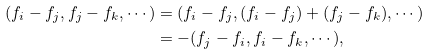Convert formula to latex. <formula><loc_0><loc_0><loc_500><loc_500>( f _ { i } - f _ { j } , f _ { j } - f _ { k } , \cdots ) & = ( f _ { i } - f _ { j } , ( f _ { i } - f _ { j } ) + ( f _ { j } - f _ { k } ) , \cdots ) \\ & = - ( f _ { j } - f _ { i } , f _ { i } - f _ { k } , \cdots ) ,</formula> 